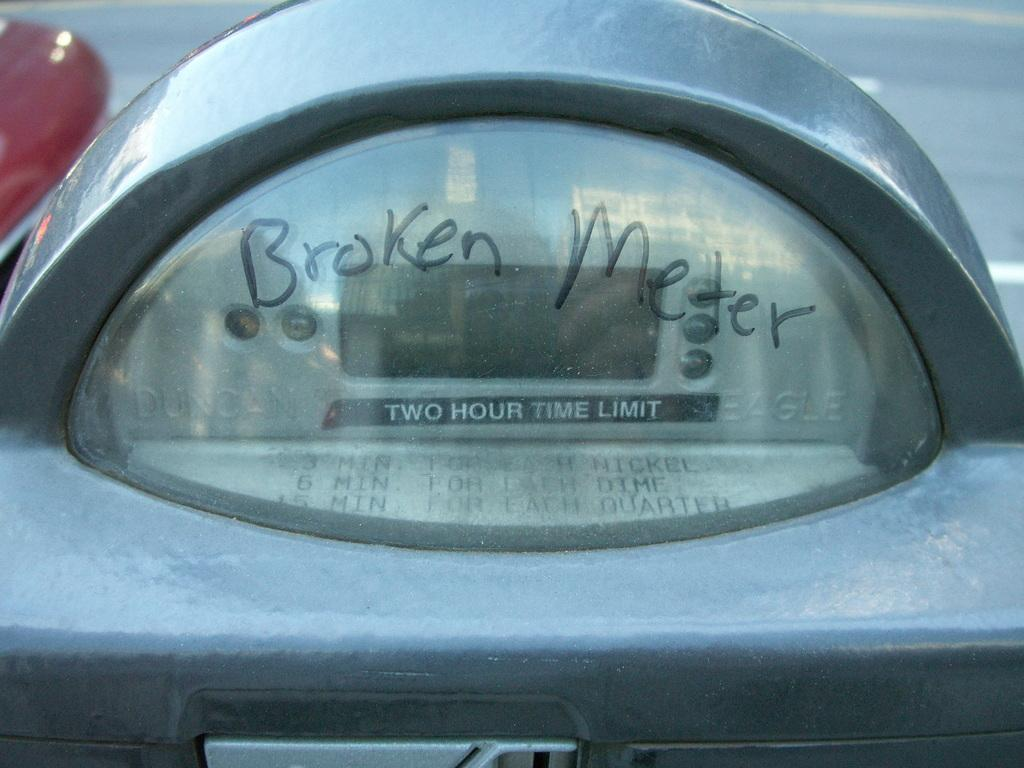<image>
Relay a brief, clear account of the picture shown. A meter with broken meter in sharpie written on it. 